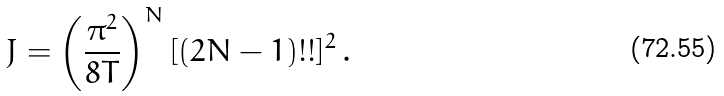Convert formula to latex. <formula><loc_0><loc_0><loc_500><loc_500>J = \left ( \frac { \pi ^ { 2 } } { 8 T } \right ) ^ { N } [ ( 2 N - 1 ) ! ! ] ^ { 2 } \, .</formula> 